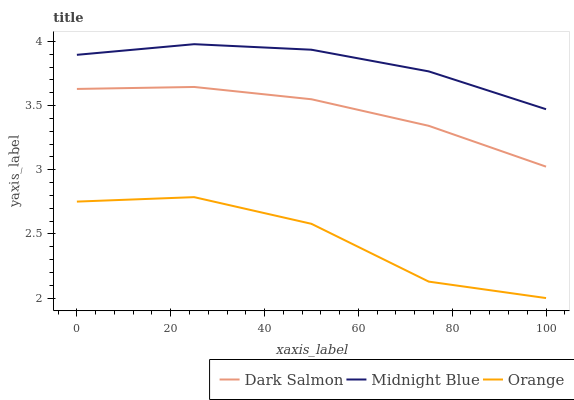Does Orange have the minimum area under the curve?
Answer yes or no. Yes. Does Midnight Blue have the maximum area under the curve?
Answer yes or no. Yes. Does Dark Salmon have the minimum area under the curve?
Answer yes or no. No. Does Dark Salmon have the maximum area under the curve?
Answer yes or no. No. Is Dark Salmon the smoothest?
Answer yes or no. Yes. Is Orange the roughest?
Answer yes or no. Yes. Is Midnight Blue the smoothest?
Answer yes or no. No. Is Midnight Blue the roughest?
Answer yes or no. No. Does Dark Salmon have the lowest value?
Answer yes or no. No. Does Midnight Blue have the highest value?
Answer yes or no. Yes. Does Dark Salmon have the highest value?
Answer yes or no. No. Is Orange less than Midnight Blue?
Answer yes or no. Yes. Is Midnight Blue greater than Dark Salmon?
Answer yes or no. Yes. Does Orange intersect Midnight Blue?
Answer yes or no. No. 